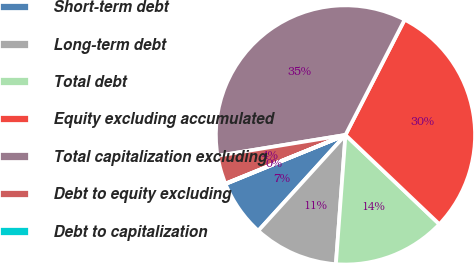<chart> <loc_0><loc_0><loc_500><loc_500><pie_chart><fcel>Short-term debt<fcel>Long-term debt<fcel>Total debt<fcel>Equity excluding accumulated<fcel>Total capitalization excluding<fcel>Debt to equity excluding<fcel>Debt to capitalization<nl><fcel>7.07%<fcel>10.57%<fcel>14.08%<fcel>29.55%<fcel>35.12%<fcel>3.56%<fcel>0.05%<nl></chart> 